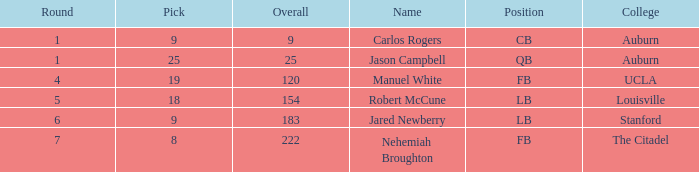Which college featured a combined pick of 9? Auburn. 